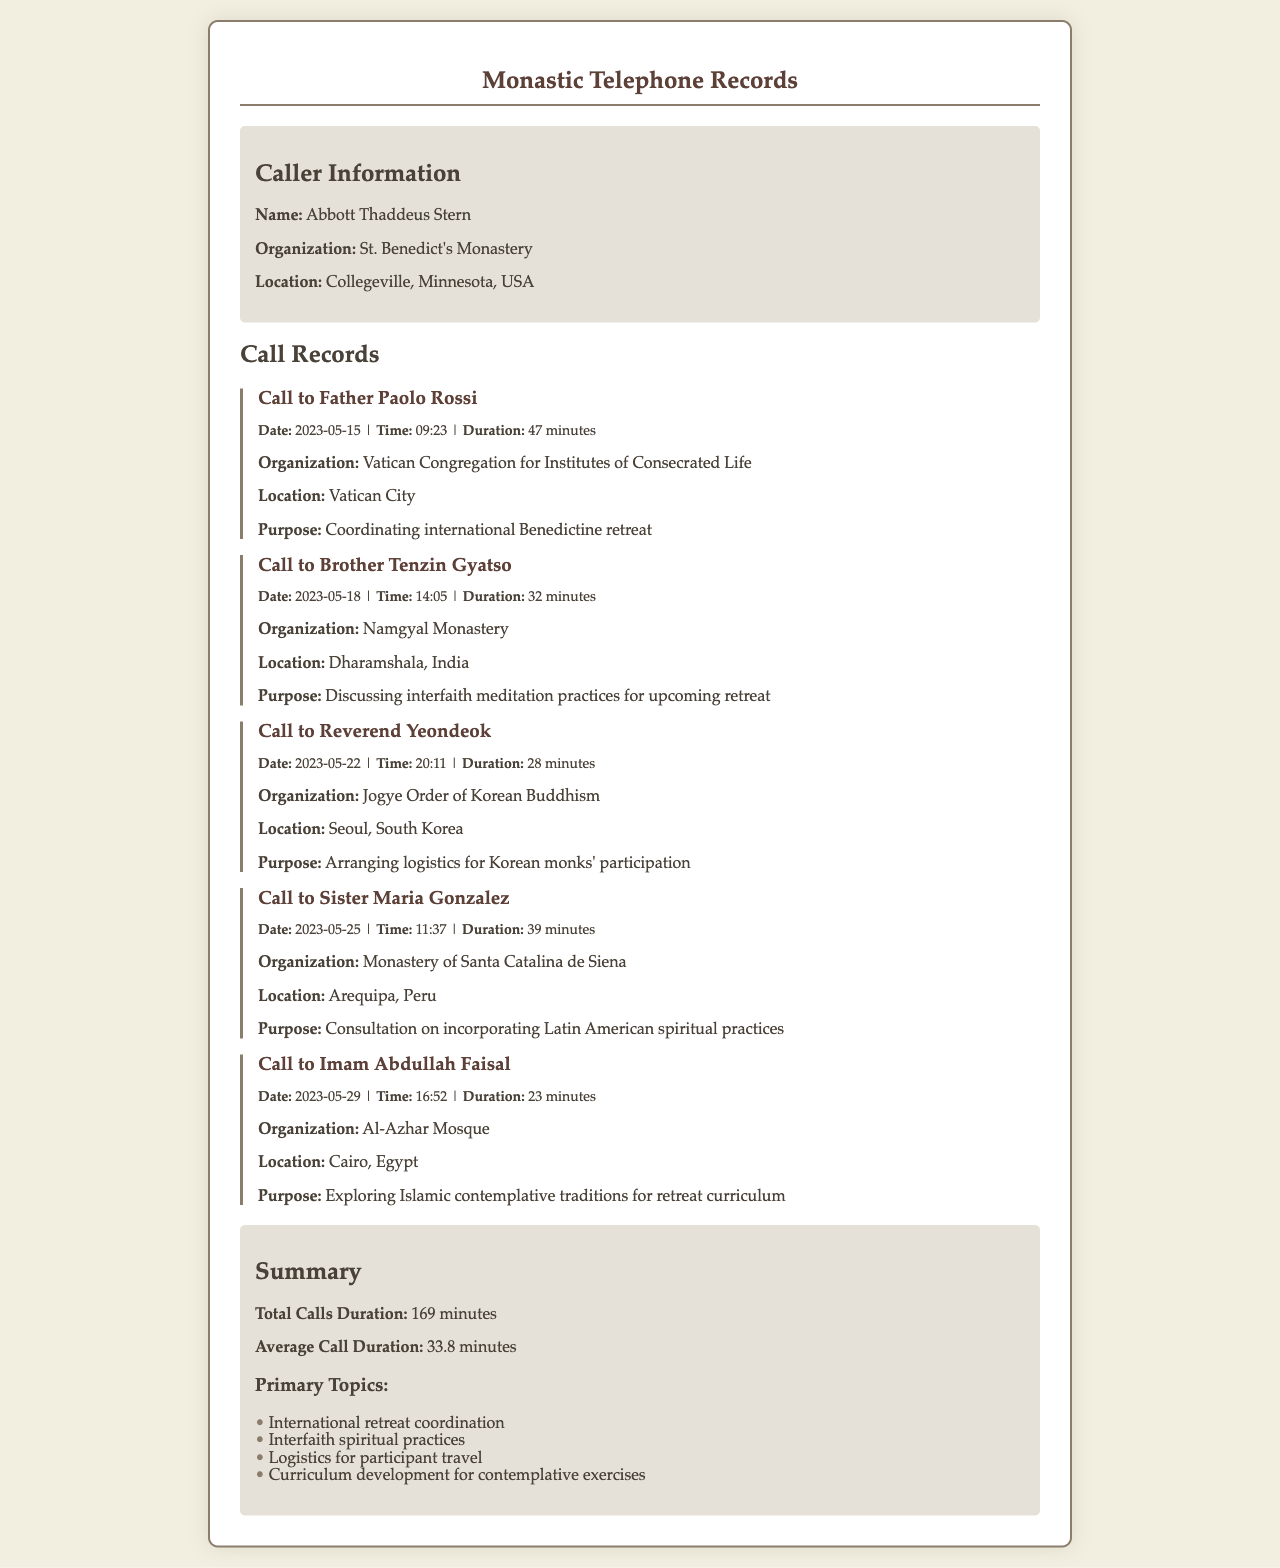What is the name of the caller? The caller's name is stated at the beginning of the document.
Answer: Abbott Thaddeus Stern What is the purpose of the call to Father Paolo Rossi? The purpose of the call is mentioned in the details of the call record.
Answer: Coordinating international Benedictine retreat When did the call to Brother Tenzin Gyatso take place? The date of the call is specified in the call details.
Answer: 2023-05-18 How long was the call with Imam Abdullah Faisal? The duration of the call is provided in the call details.
Answer: 23 minutes What organization is located in Vatican City? The document specifies the organization associated with the call to Father Paolo Rossi.
Answer: Vatican Congregation for Institutes of Consecrated Life What was the average call duration? The average call duration is summarized at the end of the document.
Answer: 33.8 minutes What is one of the primary topics discussed in the calls? Primary topics are listed in the summary section of the document.
Answer: International retreat coordination Which country is Brother Tenzin Gyatso located in? The location of Brother Tenzin Gyatso is mentioned in the call details.
Answer: Dharamshala, India How many total calls were made? The document provides a summary that includes total call duration, but the number of calls can be derived from the list of call records.
Answer: 5 